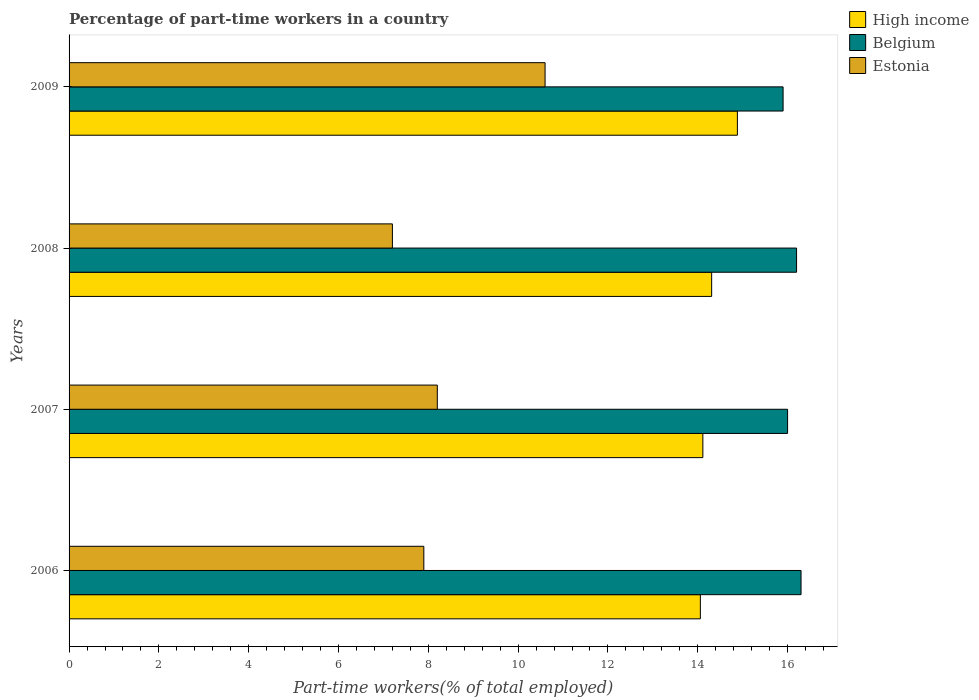How many different coloured bars are there?
Your response must be concise. 3. What is the label of the 3rd group of bars from the top?
Provide a succinct answer. 2007. What is the percentage of part-time workers in Estonia in 2009?
Offer a terse response. 10.6. Across all years, what is the maximum percentage of part-time workers in High income?
Provide a short and direct response. 14.88. Across all years, what is the minimum percentage of part-time workers in Belgium?
Provide a succinct answer. 15.9. In which year was the percentage of part-time workers in Belgium maximum?
Keep it short and to the point. 2006. What is the total percentage of part-time workers in Estonia in the graph?
Offer a very short reply. 33.9. What is the difference between the percentage of part-time workers in High income in 2006 and that in 2009?
Offer a terse response. -0.82. What is the difference between the percentage of part-time workers in Belgium in 2008 and the percentage of part-time workers in High income in 2007?
Provide a succinct answer. 2.09. What is the average percentage of part-time workers in Estonia per year?
Your answer should be very brief. 8.48. In the year 2008, what is the difference between the percentage of part-time workers in High income and percentage of part-time workers in Estonia?
Your answer should be compact. 7.11. In how many years, is the percentage of part-time workers in High income greater than 1.2000000000000002 %?
Your answer should be very brief. 4. What is the ratio of the percentage of part-time workers in High income in 2006 to that in 2009?
Offer a terse response. 0.94. What is the difference between the highest and the second highest percentage of part-time workers in High income?
Provide a short and direct response. 0.57. What is the difference between the highest and the lowest percentage of part-time workers in Belgium?
Offer a terse response. 0.4. What does the 1st bar from the bottom in 2006 represents?
Provide a short and direct response. High income. How many bars are there?
Offer a terse response. 12. Are the values on the major ticks of X-axis written in scientific E-notation?
Ensure brevity in your answer.  No. Does the graph contain grids?
Provide a succinct answer. No. Where does the legend appear in the graph?
Your response must be concise. Top right. How many legend labels are there?
Provide a short and direct response. 3. What is the title of the graph?
Provide a short and direct response. Percentage of part-time workers in a country. What is the label or title of the X-axis?
Ensure brevity in your answer.  Part-time workers(% of total employed). What is the Part-time workers(% of total employed) of High income in 2006?
Ensure brevity in your answer.  14.06. What is the Part-time workers(% of total employed) in Belgium in 2006?
Make the answer very short. 16.3. What is the Part-time workers(% of total employed) of Estonia in 2006?
Ensure brevity in your answer.  7.9. What is the Part-time workers(% of total employed) of High income in 2007?
Ensure brevity in your answer.  14.11. What is the Part-time workers(% of total employed) in Belgium in 2007?
Keep it short and to the point. 16. What is the Part-time workers(% of total employed) in Estonia in 2007?
Provide a short and direct response. 8.2. What is the Part-time workers(% of total employed) in High income in 2008?
Your response must be concise. 14.31. What is the Part-time workers(% of total employed) of Belgium in 2008?
Make the answer very short. 16.2. What is the Part-time workers(% of total employed) of Estonia in 2008?
Make the answer very short. 7.2. What is the Part-time workers(% of total employed) of High income in 2009?
Provide a short and direct response. 14.88. What is the Part-time workers(% of total employed) in Belgium in 2009?
Provide a short and direct response. 15.9. What is the Part-time workers(% of total employed) of Estonia in 2009?
Your answer should be very brief. 10.6. Across all years, what is the maximum Part-time workers(% of total employed) of High income?
Your response must be concise. 14.88. Across all years, what is the maximum Part-time workers(% of total employed) in Belgium?
Your response must be concise. 16.3. Across all years, what is the maximum Part-time workers(% of total employed) in Estonia?
Offer a very short reply. 10.6. Across all years, what is the minimum Part-time workers(% of total employed) of High income?
Offer a terse response. 14.06. Across all years, what is the minimum Part-time workers(% of total employed) in Belgium?
Make the answer very short. 15.9. Across all years, what is the minimum Part-time workers(% of total employed) of Estonia?
Make the answer very short. 7.2. What is the total Part-time workers(% of total employed) in High income in the graph?
Your answer should be very brief. 57.36. What is the total Part-time workers(% of total employed) of Belgium in the graph?
Provide a succinct answer. 64.4. What is the total Part-time workers(% of total employed) of Estonia in the graph?
Your response must be concise. 33.9. What is the difference between the Part-time workers(% of total employed) of High income in 2006 and that in 2007?
Ensure brevity in your answer.  -0.06. What is the difference between the Part-time workers(% of total employed) of Belgium in 2006 and that in 2007?
Your answer should be very brief. 0.3. What is the difference between the Part-time workers(% of total employed) of Estonia in 2006 and that in 2007?
Provide a short and direct response. -0.3. What is the difference between the Part-time workers(% of total employed) of High income in 2006 and that in 2008?
Offer a terse response. -0.25. What is the difference between the Part-time workers(% of total employed) in Estonia in 2006 and that in 2008?
Offer a terse response. 0.7. What is the difference between the Part-time workers(% of total employed) in High income in 2006 and that in 2009?
Ensure brevity in your answer.  -0.82. What is the difference between the Part-time workers(% of total employed) of High income in 2007 and that in 2008?
Your answer should be very brief. -0.2. What is the difference between the Part-time workers(% of total employed) in High income in 2007 and that in 2009?
Your answer should be compact. -0.77. What is the difference between the Part-time workers(% of total employed) of High income in 2008 and that in 2009?
Provide a short and direct response. -0.57. What is the difference between the Part-time workers(% of total employed) in High income in 2006 and the Part-time workers(% of total employed) in Belgium in 2007?
Your answer should be compact. -1.94. What is the difference between the Part-time workers(% of total employed) of High income in 2006 and the Part-time workers(% of total employed) of Estonia in 2007?
Provide a succinct answer. 5.86. What is the difference between the Part-time workers(% of total employed) of High income in 2006 and the Part-time workers(% of total employed) of Belgium in 2008?
Keep it short and to the point. -2.14. What is the difference between the Part-time workers(% of total employed) of High income in 2006 and the Part-time workers(% of total employed) of Estonia in 2008?
Ensure brevity in your answer.  6.86. What is the difference between the Part-time workers(% of total employed) in Belgium in 2006 and the Part-time workers(% of total employed) in Estonia in 2008?
Your answer should be compact. 9.1. What is the difference between the Part-time workers(% of total employed) of High income in 2006 and the Part-time workers(% of total employed) of Belgium in 2009?
Your answer should be very brief. -1.84. What is the difference between the Part-time workers(% of total employed) of High income in 2006 and the Part-time workers(% of total employed) of Estonia in 2009?
Provide a short and direct response. 3.46. What is the difference between the Part-time workers(% of total employed) of High income in 2007 and the Part-time workers(% of total employed) of Belgium in 2008?
Give a very brief answer. -2.09. What is the difference between the Part-time workers(% of total employed) of High income in 2007 and the Part-time workers(% of total employed) of Estonia in 2008?
Give a very brief answer. 6.91. What is the difference between the Part-time workers(% of total employed) in High income in 2007 and the Part-time workers(% of total employed) in Belgium in 2009?
Your answer should be compact. -1.79. What is the difference between the Part-time workers(% of total employed) of High income in 2007 and the Part-time workers(% of total employed) of Estonia in 2009?
Give a very brief answer. 3.51. What is the difference between the Part-time workers(% of total employed) in Belgium in 2007 and the Part-time workers(% of total employed) in Estonia in 2009?
Provide a short and direct response. 5.4. What is the difference between the Part-time workers(% of total employed) in High income in 2008 and the Part-time workers(% of total employed) in Belgium in 2009?
Give a very brief answer. -1.59. What is the difference between the Part-time workers(% of total employed) of High income in 2008 and the Part-time workers(% of total employed) of Estonia in 2009?
Provide a short and direct response. 3.71. What is the difference between the Part-time workers(% of total employed) of Belgium in 2008 and the Part-time workers(% of total employed) of Estonia in 2009?
Ensure brevity in your answer.  5.6. What is the average Part-time workers(% of total employed) in High income per year?
Provide a succinct answer. 14.34. What is the average Part-time workers(% of total employed) of Belgium per year?
Your answer should be compact. 16.1. What is the average Part-time workers(% of total employed) of Estonia per year?
Keep it short and to the point. 8.47. In the year 2006, what is the difference between the Part-time workers(% of total employed) in High income and Part-time workers(% of total employed) in Belgium?
Your response must be concise. -2.24. In the year 2006, what is the difference between the Part-time workers(% of total employed) of High income and Part-time workers(% of total employed) of Estonia?
Your answer should be compact. 6.16. In the year 2007, what is the difference between the Part-time workers(% of total employed) in High income and Part-time workers(% of total employed) in Belgium?
Your answer should be compact. -1.89. In the year 2007, what is the difference between the Part-time workers(% of total employed) of High income and Part-time workers(% of total employed) of Estonia?
Offer a very short reply. 5.91. In the year 2008, what is the difference between the Part-time workers(% of total employed) of High income and Part-time workers(% of total employed) of Belgium?
Your answer should be compact. -1.89. In the year 2008, what is the difference between the Part-time workers(% of total employed) of High income and Part-time workers(% of total employed) of Estonia?
Give a very brief answer. 7.11. In the year 2009, what is the difference between the Part-time workers(% of total employed) of High income and Part-time workers(% of total employed) of Belgium?
Your answer should be compact. -1.02. In the year 2009, what is the difference between the Part-time workers(% of total employed) in High income and Part-time workers(% of total employed) in Estonia?
Provide a short and direct response. 4.28. What is the ratio of the Part-time workers(% of total employed) of Belgium in 2006 to that in 2007?
Your response must be concise. 1.02. What is the ratio of the Part-time workers(% of total employed) of Estonia in 2006 to that in 2007?
Make the answer very short. 0.96. What is the ratio of the Part-time workers(% of total employed) of High income in 2006 to that in 2008?
Provide a short and direct response. 0.98. What is the ratio of the Part-time workers(% of total employed) in Belgium in 2006 to that in 2008?
Keep it short and to the point. 1.01. What is the ratio of the Part-time workers(% of total employed) in Estonia in 2006 to that in 2008?
Your answer should be very brief. 1.1. What is the ratio of the Part-time workers(% of total employed) in High income in 2006 to that in 2009?
Ensure brevity in your answer.  0.94. What is the ratio of the Part-time workers(% of total employed) in Belgium in 2006 to that in 2009?
Ensure brevity in your answer.  1.03. What is the ratio of the Part-time workers(% of total employed) in Estonia in 2006 to that in 2009?
Provide a short and direct response. 0.75. What is the ratio of the Part-time workers(% of total employed) in High income in 2007 to that in 2008?
Offer a very short reply. 0.99. What is the ratio of the Part-time workers(% of total employed) in Estonia in 2007 to that in 2008?
Offer a very short reply. 1.14. What is the ratio of the Part-time workers(% of total employed) of High income in 2007 to that in 2009?
Provide a short and direct response. 0.95. What is the ratio of the Part-time workers(% of total employed) of Belgium in 2007 to that in 2009?
Your answer should be very brief. 1.01. What is the ratio of the Part-time workers(% of total employed) of Estonia in 2007 to that in 2009?
Provide a short and direct response. 0.77. What is the ratio of the Part-time workers(% of total employed) of High income in 2008 to that in 2009?
Your answer should be very brief. 0.96. What is the ratio of the Part-time workers(% of total employed) in Belgium in 2008 to that in 2009?
Provide a short and direct response. 1.02. What is the ratio of the Part-time workers(% of total employed) of Estonia in 2008 to that in 2009?
Provide a short and direct response. 0.68. What is the difference between the highest and the second highest Part-time workers(% of total employed) in High income?
Offer a very short reply. 0.57. What is the difference between the highest and the second highest Part-time workers(% of total employed) of Belgium?
Your response must be concise. 0.1. What is the difference between the highest and the lowest Part-time workers(% of total employed) in High income?
Give a very brief answer. 0.82. 